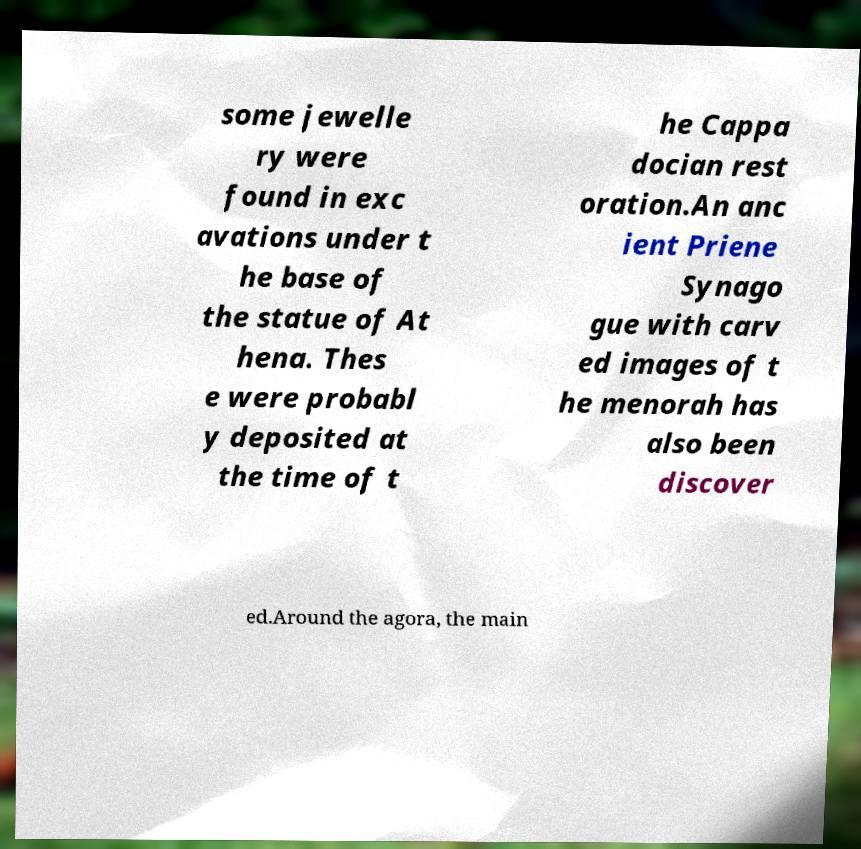Could you extract and type out the text from this image? some jewelle ry were found in exc avations under t he base of the statue of At hena. Thes e were probabl y deposited at the time of t he Cappa docian rest oration.An anc ient Priene Synago gue with carv ed images of t he menorah has also been discover ed.Around the agora, the main 